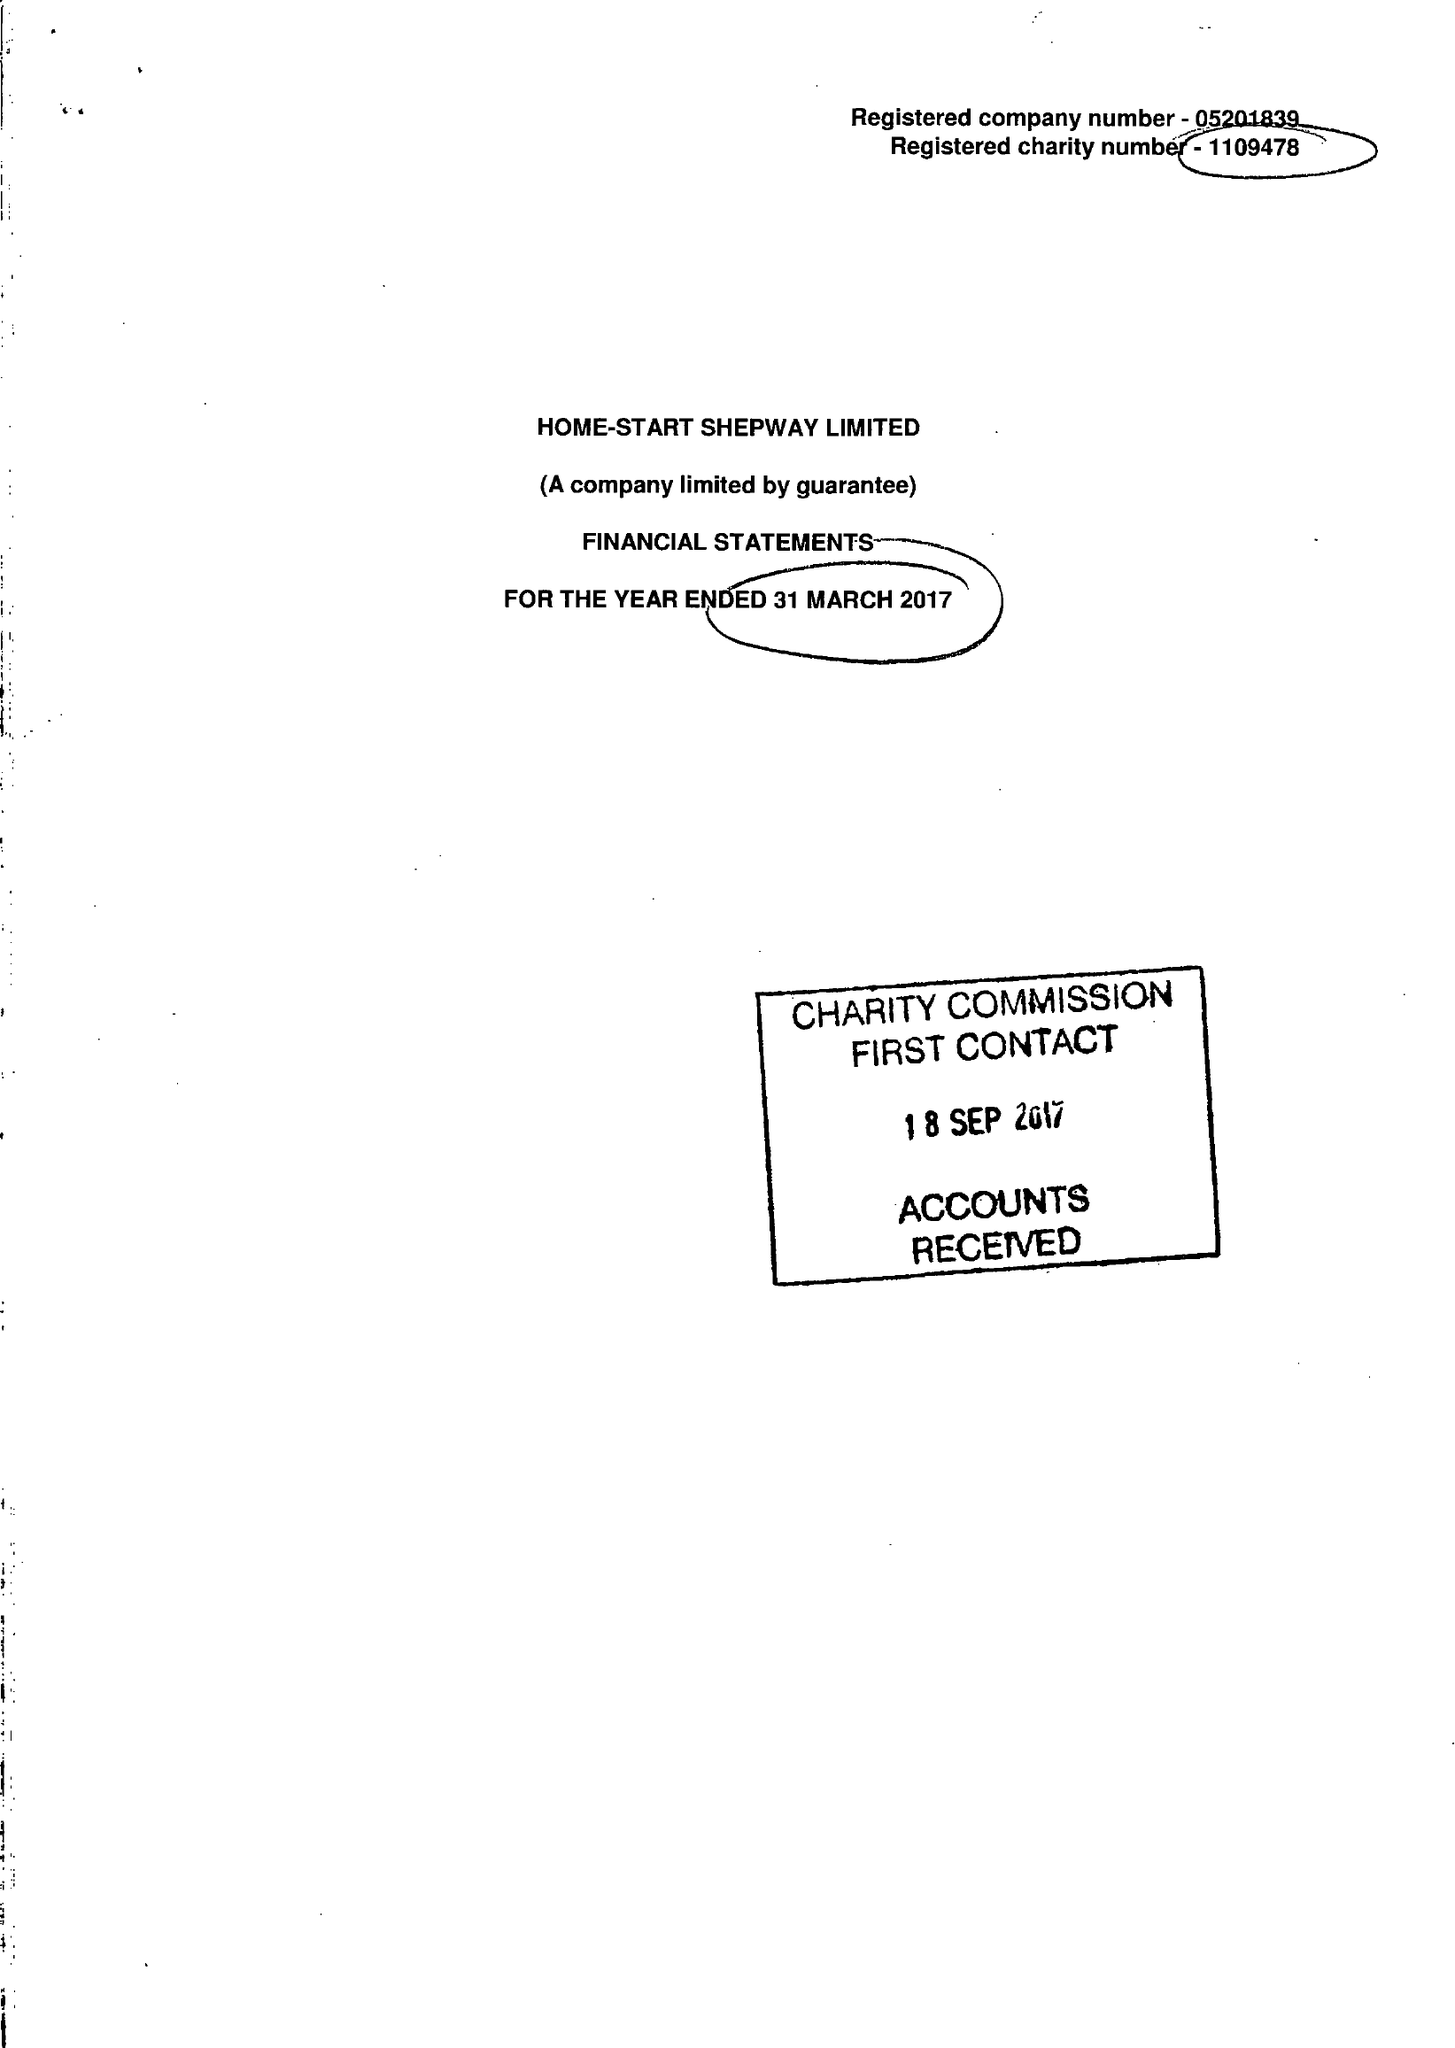What is the value for the income_annually_in_british_pounds?
Answer the question using a single word or phrase. 219081.00 